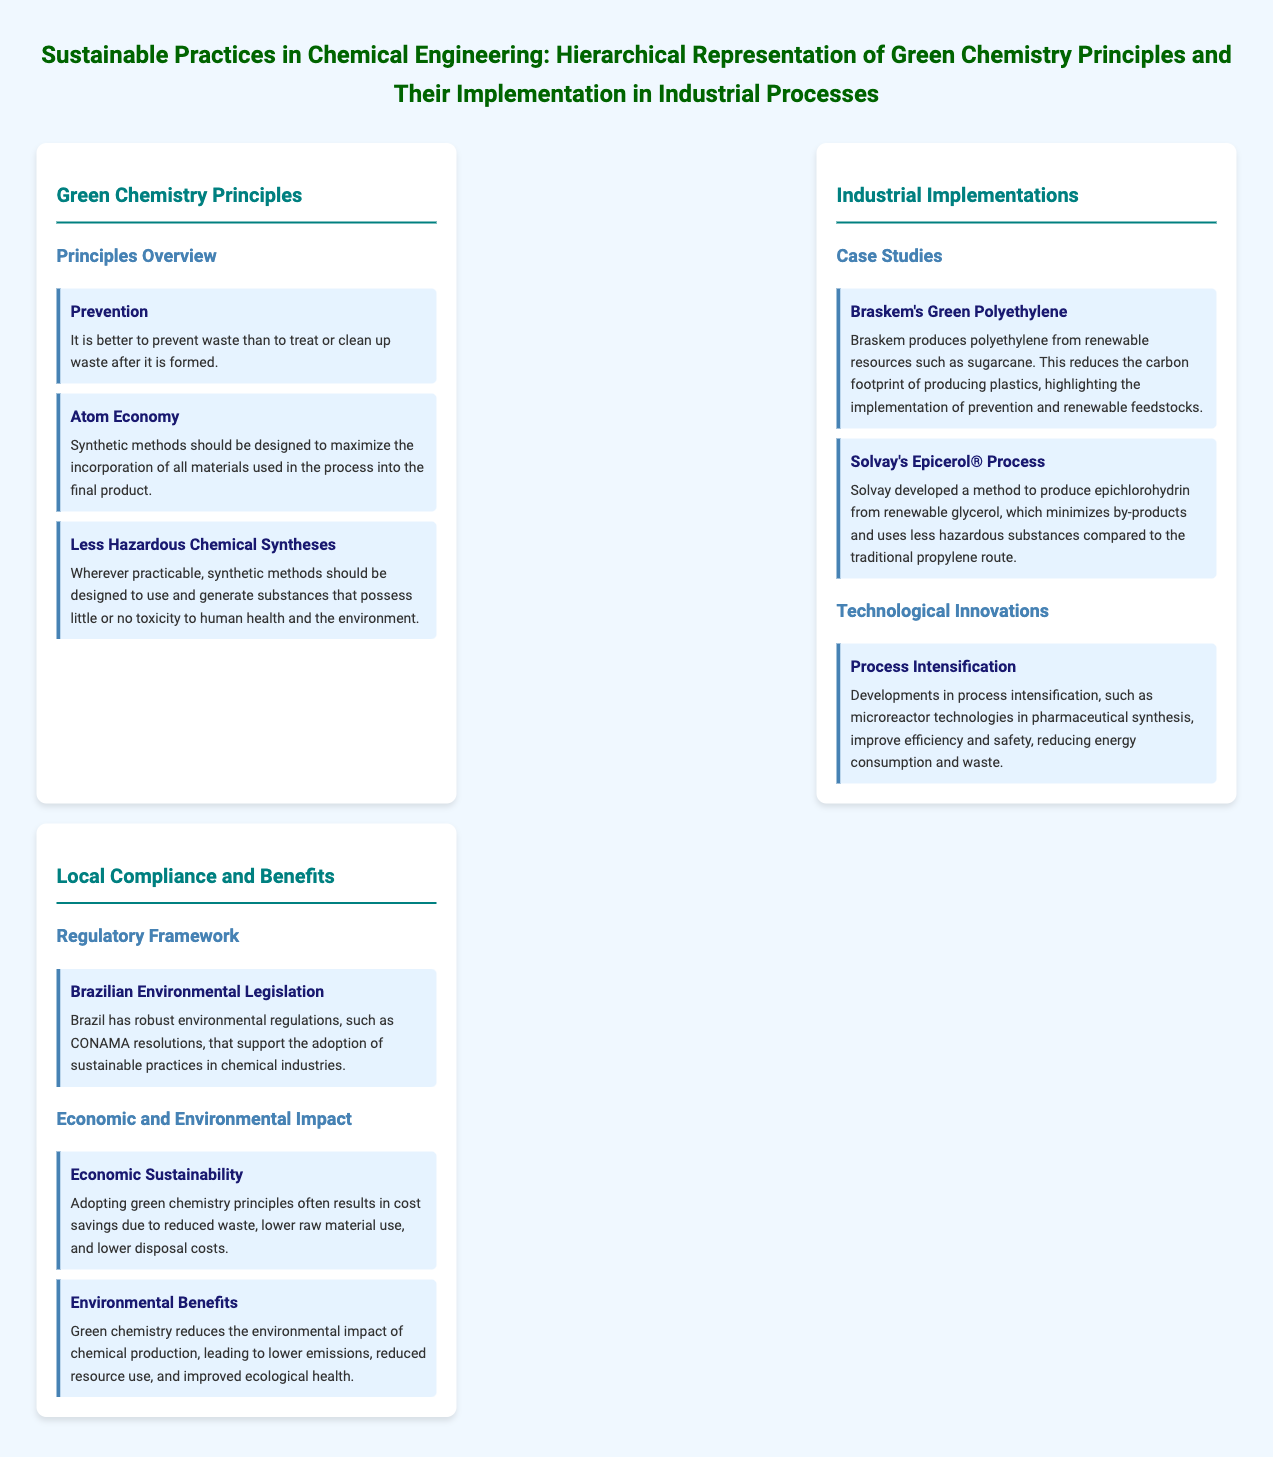What are the principles of green chemistry? The principles of green chemistry are outlined in the document, highlighting key concepts such as prevention, atom economy, and less hazardous chemical syntheses.
Answer: Prevention, Atom Economy, Less Hazardous Chemical Syntheses What is Braskem's green product? Braskem produces polyethylene from renewable resources such as sugarcane, as described in the case studies section.
Answer: Green Polyethylene What is one technological innovation mentioned? The document discusses process intensification, specifically mentioning microreactor technologies in pharmaceutical synthesis as an innovative approach.
Answer: Process Intensification Which regulatory framework supports sustainable practices in Brazil? The document specifies Brazilian environmental legislation, including CONAMA resolutions, as a framework that supports sustainable practices in the chemical industry.
Answer: Brazilian Environmental Legislation What is one economic benefit of adopting green chemistry principles? The document indicates that adopting green chemistry principles can lead to cost savings due to various factors like reduced waste and lower raw material use.
Answer: Cost Savings 